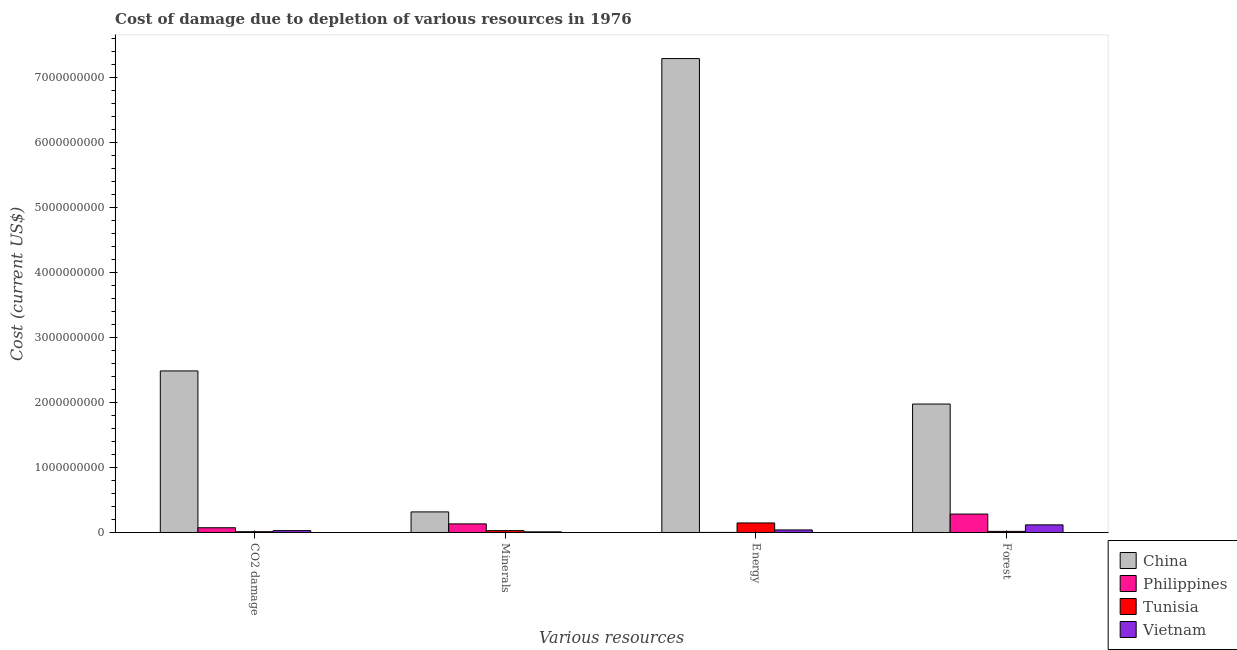How many groups of bars are there?
Offer a very short reply. 4. Are the number of bars on each tick of the X-axis equal?
Provide a short and direct response. Yes. How many bars are there on the 2nd tick from the left?
Offer a very short reply. 4. What is the label of the 1st group of bars from the left?
Provide a short and direct response. CO2 damage. What is the cost of damage due to depletion of energy in China?
Make the answer very short. 7.29e+09. Across all countries, what is the maximum cost of damage due to depletion of minerals?
Keep it short and to the point. 3.17e+08. Across all countries, what is the minimum cost of damage due to depletion of energy?
Offer a terse response. 1.14e+06. In which country was the cost of damage due to depletion of minerals minimum?
Offer a very short reply. Vietnam. What is the total cost of damage due to depletion of coal in the graph?
Your answer should be very brief. 2.60e+09. What is the difference between the cost of damage due to depletion of energy in Vietnam and that in China?
Make the answer very short. -7.26e+09. What is the difference between the cost of damage due to depletion of coal in Tunisia and the cost of damage due to depletion of minerals in China?
Your response must be concise. -3.04e+08. What is the average cost of damage due to depletion of forests per country?
Your response must be concise. 5.99e+08. What is the difference between the cost of damage due to depletion of coal and cost of damage due to depletion of energy in Tunisia?
Provide a succinct answer. -1.35e+08. In how many countries, is the cost of damage due to depletion of coal greater than 1600000000 US$?
Ensure brevity in your answer.  1. What is the ratio of the cost of damage due to depletion of coal in Philippines to that in China?
Keep it short and to the point. 0.03. Is the cost of damage due to depletion of forests in Philippines less than that in Vietnam?
Ensure brevity in your answer.  No. What is the difference between the highest and the second highest cost of damage due to depletion of forests?
Your answer should be compact. 1.69e+09. What is the difference between the highest and the lowest cost of damage due to depletion of forests?
Keep it short and to the point. 1.96e+09. Is it the case that in every country, the sum of the cost of damage due to depletion of forests and cost of damage due to depletion of minerals is greater than the sum of cost of damage due to depletion of coal and cost of damage due to depletion of energy?
Make the answer very short. No. What does the 2nd bar from the right in Energy represents?
Make the answer very short. Tunisia. How many bars are there?
Offer a very short reply. 16. What is the difference between two consecutive major ticks on the Y-axis?
Your answer should be compact. 1.00e+09. Where does the legend appear in the graph?
Offer a terse response. Bottom right. How are the legend labels stacked?
Ensure brevity in your answer.  Vertical. What is the title of the graph?
Provide a short and direct response. Cost of damage due to depletion of various resources in 1976 . What is the label or title of the X-axis?
Provide a succinct answer. Various resources. What is the label or title of the Y-axis?
Offer a very short reply. Cost (current US$). What is the Cost (current US$) in China in CO2 damage?
Offer a very short reply. 2.49e+09. What is the Cost (current US$) of Philippines in CO2 damage?
Give a very brief answer. 7.30e+07. What is the Cost (current US$) of Tunisia in CO2 damage?
Ensure brevity in your answer.  1.22e+07. What is the Cost (current US$) in Vietnam in CO2 damage?
Offer a very short reply. 2.89e+07. What is the Cost (current US$) in China in Minerals?
Provide a succinct answer. 3.17e+08. What is the Cost (current US$) in Philippines in Minerals?
Give a very brief answer. 1.33e+08. What is the Cost (current US$) in Tunisia in Minerals?
Your response must be concise. 2.87e+07. What is the Cost (current US$) of Vietnam in Minerals?
Give a very brief answer. 9.66e+06. What is the Cost (current US$) in China in Energy?
Provide a short and direct response. 7.29e+09. What is the Cost (current US$) of Philippines in Energy?
Provide a succinct answer. 1.14e+06. What is the Cost (current US$) of Tunisia in Energy?
Your response must be concise. 1.47e+08. What is the Cost (current US$) of Vietnam in Energy?
Give a very brief answer. 3.92e+07. What is the Cost (current US$) in China in Forest?
Keep it short and to the point. 1.98e+09. What is the Cost (current US$) in Philippines in Forest?
Give a very brief answer. 2.84e+08. What is the Cost (current US$) of Tunisia in Forest?
Ensure brevity in your answer.  1.70e+07. What is the Cost (current US$) in Vietnam in Forest?
Your answer should be very brief. 1.17e+08. Across all Various resources, what is the maximum Cost (current US$) of China?
Your answer should be compact. 7.29e+09. Across all Various resources, what is the maximum Cost (current US$) of Philippines?
Provide a succinct answer. 2.84e+08. Across all Various resources, what is the maximum Cost (current US$) in Tunisia?
Keep it short and to the point. 1.47e+08. Across all Various resources, what is the maximum Cost (current US$) in Vietnam?
Ensure brevity in your answer.  1.17e+08. Across all Various resources, what is the minimum Cost (current US$) of China?
Make the answer very short. 3.17e+08. Across all Various resources, what is the minimum Cost (current US$) in Philippines?
Your answer should be very brief. 1.14e+06. Across all Various resources, what is the minimum Cost (current US$) of Tunisia?
Your response must be concise. 1.22e+07. Across all Various resources, what is the minimum Cost (current US$) of Vietnam?
Your answer should be compact. 9.66e+06. What is the total Cost (current US$) of China in the graph?
Ensure brevity in your answer.  1.21e+1. What is the total Cost (current US$) in Philippines in the graph?
Your response must be concise. 4.90e+08. What is the total Cost (current US$) in Tunisia in the graph?
Provide a succinct answer. 2.05e+08. What is the total Cost (current US$) in Vietnam in the graph?
Offer a very short reply. 1.95e+08. What is the difference between the Cost (current US$) in China in CO2 damage and that in Minerals?
Make the answer very short. 2.17e+09. What is the difference between the Cost (current US$) of Philippines in CO2 damage and that in Minerals?
Keep it short and to the point. -5.95e+07. What is the difference between the Cost (current US$) of Tunisia in CO2 damage and that in Minerals?
Keep it short and to the point. -1.65e+07. What is the difference between the Cost (current US$) in Vietnam in CO2 damage and that in Minerals?
Ensure brevity in your answer.  1.93e+07. What is the difference between the Cost (current US$) of China in CO2 damage and that in Energy?
Your response must be concise. -4.81e+09. What is the difference between the Cost (current US$) of Philippines in CO2 damage and that in Energy?
Your answer should be very brief. 7.19e+07. What is the difference between the Cost (current US$) of Tunisia in CO2 damage and that in Energy?
Make the answer very short. -1.35e+08. What is the difference between the Cost (current US$) in Vietnam in CO2 damage and that in Energy?
Your answer should be compact. -1.03e+07. What is the difference between the Cost (current US$) of China in CO2 damage and that in Forest?
Give a very brief answer. 5.09e+08. What is the difference between the Cost (current US$) of Philippines in CO2 damage and that in Forest?
Make the answer very short. -2.11e+08. What is the difference between the Cost (current US$) in Tunisia in CO2 damage and that in Forest?
Make the answer very short. -4.79e+06. What is the difference between the Cost (current US$) in Vietnam in CO2 damage and that in Forest?
Your answer should be very brief. -8.84e+07. What is the difference between the Cost (current US$) of China in Minerals and that in Energy?
Keep it short and to the point. -6.98e+09. What is the difference between the Cost (current US$) of Philippines in Minerals and that in Energy?
Give a very brief answer. 1.31e+08. What is the difference between the Cost (current US$) of Tunisia in Minerals and that in Energy?
Your response must be concise. -1.18e+08. What is the difference between the Cost (current US$) in Vietnam in Minerals and that in Energy?
Ensure brevity in your answer.  -2.96e+07. What is the difference between the Cost (current US$) in China in Minerals and that in Forest?
Give a very brief answer. -1.66e+09. What is the difference between the Cost (current US$) in Philippines in Minerals and that in Forest?
Give a very brief answer. -1.51e+08. What is the difference between the Cost (current US$) of Tunisia in Minerals and that in Forest?
Your answer should be very brief. 1.17e+07. What is the difference between the Cost (current US$) of Vietnam in Minerals and that in Forest?
Your response must be concise. -1.08e+08. What is the difference between the Cost (current US$) in China in Energy and that in Forest?
Your response must be concise. 5.32e+09. What is the difference between the Cost (current US$) of Philippines in Energy and that in Forest?
Your answer should be very brief. -2.82e+08. What is the difference between the Cost (current US$) in Tunisia in Energy and that in Forest?
Offer a very short reply. 1.30e+08. What is the difference between the Cost (current US$) in Vietnam in Energy and that in Forest?
Give a very brief answer. -7.81e+07. What is the difference between the Cost (current US$) in China in CO2 damage and the Cost (current US$) in Philippines in Minerals?
Ensure brevity in your answer.  2.35e+09. What is the difference between the Cost (current US$) in China in CO2 damage and the Cost (current US$) in Tunisia in Minerals?
Keep it short and to the point. 2.46e+09. What is the difference between the Cost (current US$) in China in CO2 damage and the Cost (current US$) in Vietnam in Minerals?
Your answer should be compact. 2.48e+09. What is the difference between the Cost (current US$) of Philippines in CO2 damage and the Cost (current US$) of Tunisia in Minerals?
Give a very brief answer. 4.44e+07. What is the difference between the Cost (current US$) of Philippines in CO2 damage and the Cost (current US$) of Vietnam in Minerals?
Your answer should be very brief. 6.34e+07. What is the difference between the Cost (current US$) in Tunisia in CO2 damage and the Cost (current US$) in Vietnam in Minerals?
Offer a very short reply. 2.50e+06. What is the difference between the Cost (current US$) of China in CO2 damage and the Cost (current US$) of Philippines in Energy?
Offer a very short reply. 2.49e+09. What is the difference between the Cost (current US$) of China in CO2 damage and the Cost (current US$) of Tunisia in Energy?
Provide a succinct answer. 2.34e+09. What is the difference between the Cost (current US$) in China in CO2 damage and the Cost (current US$) in Vietnam in Energy?
Make the answer very short. 2.45e+09. What is the difference between the Cost (current US$) in Philippines in CO2 damage and the Cost (current US$) in Tunisia in Energy?
Offer a terse response. -7.38e+07. What is the difference between the Cost (current US$) in Philippines in CO2 damage and the Cost (current US$) in Vietnam in Energy?
Your answer should be very brief. 3.38e+07. What is the difference between the Cost (current US$) in Tunisia in CO2 damage and the Cost (current US$) in Vietnam in Energy?
Your response must be concise. -2.71e+07. What is the difference between the Cost (current US$) of China in CO2 damage and the Cost (current US$) of Philippines in Forest?
Offer a terse response. 2.20e+09. What is the difference between the Cost (current US$) of China in CO2 damage and the Cost (current US$) of Tunisia in Forest?
Provide a short and direct response. 2.47e+09. What is the difference between the Cost (current US$) in China in CO2 damage and the Cost (current US$) in Vietnam in Forest?
Provide a succinct answer. 2.37e+09. What is the difference between the Cost (current US$) of Philippines in CO2 damage and the Cost (current US$) of Tunisia in Forest?
Offer a very short reply. 5.61e+07. What is the difference between the Cost (current US$) in Philippines in CO2 damage and the Cost (current US$) in Vietnam in Forest?
Provide a succinct answer. -4.43e+07. What is the difference between the Cost (current US$) in Tunisia in CO2 damage and the Cost (current US$) in Vietnam in Forest?
Provide a short and direct response. -1.05e+08. What is the difference between the Cost (current US$) of China in Minerals and the Cost (current US$) of Philippines in Energy?
Offer a very short reply. 3.16e+08. What is the difference between the Cost (current US$) in China in Minerals and the Cost (current US$) in Tunisia in Energy?
Your answer should be compact. 1.70e+08. What is the difference between the Cost (current US$) in China in Minerals and the Cost (current US$) in Vietnam in Energy?
Your answer should be very brief. 2.77e+08. What is the difference between the Cost (current US$) in Philippines in Minerals and the Cost (current US$) in Tunisia in Energy?
Ensure brevity in your answer.  -1.44e+07. What is the difference between the Cost (current US$) of Philippines in Minerals and the Cost (current US$) of Vietnam in Energy?
Provide a short and direct response. 9.33e+07. What is the difference between the Cost (current US$) in Tunisia in Minerals and the Cost (current US$) in Vietnam in Energy?
Offer a terse response. -1.06e+07. What is the difference between the Cost (current US$) in China in Minerals and the Cost (current US$) in Philippines in Forest?
Provide a succinct answer. 3.31e+07. What is the difference between the Cost (current US$) of China in Minerals and the Cost (current US$) of Tunisia in Forest?
Your answer should be compact. 3.00e+08. What is the difference between the Cost (current US$) of China in Minerals and the Cost (current US$) of Vietnam in Forest?
Give a very brief answer. 1.99e+08. What is the difference between the Cost (current US$) of Philippines in Minerals and the Cost (current US$) of Tunisia in Forest?
Give a very brief answer. 1.16e+08. What is the difference between the Cost (current US$) in Philippines in Minerals and the Cost (current US$) in Vietnam in Forest?
Your answer should be compact. 1.52e+07. What is the difference between the Cost (current US$) of Tunisia in Minerals and the Cost (current US$) of Vietnam in Forest?
Provide a succinct answer. -8.87e+07. What is the difference between the Cost (current US$) in China in Energy and the Cost (current US$) in Philippines in Forest?
Give a very brief answer. 7.01e+09. What is the difference between the Cost (current US$) of China in Energy and the Cost (current US$) of Tunisia in Forest?
Keep it short and to the point. 7.28e+09. What is the difference between the Cost (current US$) in China in Energy and the Cost (current US$) in Vietnam in Forest?
Make the answer very short. 7.18e+09. What is the difference between the Cost (current US$) of Philippines in Energy and the Cost (current US$) of Tunisia in Forest?
Offer a terse response. -1.58e+07. What is the difference between the Cost (current US$) of Philippines in Energy and the Cost (current US$) of Vietnam in Forest?
Keep it short and to the point. -1.16e+08. What is the difference between the Cost (current US$) of Tunisia in Energy and the Cost (current US$) of Vietnam in Forest?
Your answer should be very brief. 2.95e+07. What is the average Cost (current US$) of China per Various resources?
Your answer should be compact. 3.02e+09. What is the average Cost (current US$) of Philippines per Various resources?
Offer a very short reply. 1.23e+08. What is the average Cost (current US$) of Tunisia per Various resources?
Give a very brief answer. 5.12e+07. What is the average Cost (current US$) in Vietnam per Various resources?
Give a very brief answer. 4.88e+07. What is the difference between the Cost (current US$) in China and Cost (current US$) in Philippines in CO2 damage?
Make the answer very short. 2.41e+09. What is the difference between the Cost (current US$) in China and Cost (current US$) in Tunisia in CO2 damage?
Keep it short and to the point. 2.47e+09. What is the difference between the Cost (current US$) in China and Cost (current US$) in Vietnam in CO2 damage?
Keep it short and to the point. 2.46e+09. What is the difference between the Cost (current US$) in Philippines and Cost (current US$) in Tunisia in CO2 damage?
Offer a very short reply. 6.09e+07. What is the difference between the Cost (current US$) of Philippines and Cost (current US$) of Vietnam in CO2 damage?
Give a very brief answer. 4.41e+07. What is the difference between the Cost (current US$) of Tunisia and Cost (current US$) of Vietnam in CO2 damage?
Give a very brief answer. -1.68e+07. What is the difference between the Cost (current US$) in China and Cost (current US$) in Philippines in Minerals?
Ensure brevity in your answer.  1.84e+08. What is the difference between the Cost (current US$) of China and Cost (current US$) of Tunisia in Minerals?
Offer a very short reply. 2.88e+08. What is the difference between the Cost (current US$) of China and Cost (current US$) of Vietnam in Minerals?
Your response must be concise. 3.07e+08. What is the difference between the Cost (current US$) in Philippines and Cost (current US$) in Tunisia in Minerals?
Offer a terse response. 1.04e+08. What is the difference between the Cost (current US$) in Philippines and Cost (current US$) in Vietnam in Minerals?
Your answer should be compact. 1.23e+08. What is the difference between the Cost (current US$) in Tunisia and Cost (current US$) in Vietnam in Minerals?
Your response must be concise. 1.90e+07. What is the difference between the Cost (current US$) of China and Cost (current US$) of Philippines in Energy?
Provide a succinct answer. 7.29e+09. What is the difference between the Cost (current US$) of China and Cost (current US$) of Tunisia in Energy?
Keep it short and to the point. 7.15e+09. What is the difference between the Cost (current US$) of China and Cost (current US$) of Vietnam in Energy?
Ensure brevity in your answer.  7.26e+09. What is the difference between the Cost (current US$) in Philippines and Cost (current US$) in Tunisia in Energy?
Provide a short and direct response. -1.46e+08. What is the difference between the Cost (current US$) of Philippines and Cost (current US$) of Vietnam in Energy?
Ensure brevity in your answer.  -3.81e+07. What is the difference between the Cost (current US$) of Tunisia and Cost (current US$) of Vietnam in Energy?
Give a very brief answer. 1.08e+08. What is the difference between the Cost (current US$) of China and Cost (current US$) of Philippines in Forest?
Your answer should be very brief. 1.69e+09. What is the difference between the Cost (current US$) in China and Cost (current US$) in Tunisia in Forest?
Make the answer very short. 1.96e+09. What is the difference between the Cost (current US$) of China and Cost (current US$) of Vietnam in Forest?
Keep it short and to the point. 1.86e+09. What is the difference between the Cost (current US$) in Philippines and Cost (current US$) in Tunisia in Forest?
Offer a terse response. 2.67e+08. What is the difference between the Cost (current US$) of Philippines and Cost (current US$) of Vietnam in Forest?
Make the answer very short. 1.66e+08. What is the difference between the Cost (current US$) of Tunisia and Cost (current US$) of Vietnam in Forest?
Provide a succinct answer. -1.00e+08. What is the ratio of the Cost (current US$) of China in CO2 damage to that in Minerals?
Provide a short and direct response. 7.85. What is the ratio of the Cost (current US$) in Philippines in CO2 damage to that in Minerals?
Keep it short and to the point. 0.55. What is the ratio of the Cost (current US$) in Tunisia in CO2 damage to that in Minerals?
Give a very brief answer. 0.42. What is the ratio of the Cost (current US$) of Vietnam in CO2 damage to that in Minerals?
Keep it short and to the point. 3. What is the ratio of the Cost (current US$) of China in CO2 damage to that in Energy?
Give a very brief answer. 0.34. What is the ratio of the Cost (current US$) of Philippines in CO2 damage to that in Energy?
Your answer should be very brief. 64.15. What is the ratio of the Cost (current US$) of Tunisia in CO2 damage to that in Energy?
Keep it short and to the point. 0.08. What is the ratio of the Cost (current US$) in Vietnam in CO2 damage to that in Energy?
Your response must be concise. 0.74. What is the ratio of the Cost (current US$) in China in CO2 damage to that in Forest?
Keep it short and to the point. 1.26. What is the ratio of the Cost (current US$) in Philippines in CO2 damage to that in Forest?
Offer a very short reply. 0.26. What is the ratio of the Cost (current US$) of Tunisia in CO2 damage to that in Forest?
Your answer should be compact. 0.72. What is the ratio of the Cost (current US$) of Vietnam in CO2 damage to that in Forest?
Your response must be concise. 0.25. What is the ratio of the Cost (current US$) of China in Minerals to that in Energy?
Offer a very short reply. 0.04. What is the ratio of the Cost (current US$) in Philippines in Minerals to that in Energy?
Offer a very short reply. 116.4. What is the ratio of the Cost (current US$) in Tunisia in Minerals to that in Energy?
Provide a succinct answer. 0.2. What is the ratio of the Cost (current US$) in Vietnam in Minerals to that in Energy?
Offer a very short reply. 0.25. What is the ratio of the Cost (current US$) in China in Minerals to that in Forest?
Provide a succinct answer. 0.16. What is the ratio of the Cost (current US$) in Philippines in Minerals to that in Forest?
Make the answer very short. 0.47. What is the ratio of the Cost (current US$) in Tunisia in Minerals to that in Forest?
Offer a very short reply. 1.69. What is the ratio of the Cost (current US$) of Vietnam in Minerals to that in Forest?
Ensure brevity in your answer.  0.08. What is the ratio of the Cost (current US$) in China in Energy to that in Forest?
Offer a terse response. 3.69. What is the ratio of the Cost (current US$) of Philippines in Energy to that in Forest?
Give a very brief answer. 0. What is the ratio of the Cost (current US$) in Tunisia in Energy to that in Forest?
Make the answer very short. 8.66. What is the ratio of the Cost (current US$) of Vietnam in Energy to that in Forest?
Your answer should be compact. 0.33. What is the difference between the highest and the second highest Cost (current US$) of China?
Your answer should be very brief. 4.81e+09. What is the difference between the highest and the second highest Cost (current US$) of Philippines?
Provide a short and direct response. 1.51e+08. What is the difference between the highest and the second highest Cost (current US$) of Tunisia?
Your answer should be very brief. 1.18e+08. What is the difference between the highest and the second highest Cost (current US$) of Vietnam?
Give a very brief answer. 7.81e+07. What is the difference between the highest and the lowest Cost (current US$) of China?
Make the answer very short. 6.98e+09. What is the difference between the highest and the lowest Cost (current US$) in Philippines?
Provide a short and direct response. 2.82e+08. What is the difference between the highest and the lowest Cost (current US$) of Tunisia?
Provide a succinct answer. 1.35e+08. What is the difference between the highest and the lowest Cost (current US$) in Vietnam?
Ensure brevity in your answer.  1.08e+08. 